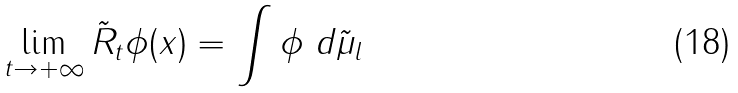Convert formula to latex. <formula><loc_0><loc_0><loc_500><loc_500>\lim _ { t \to + \infty } \tilde { R } _ { t } \phi ( x ) = \int \phi \ d \tilde { \mu } _ { l }</formula> 